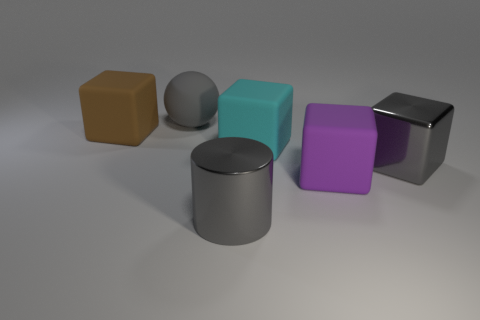Subtract all cyan cylinders. Subtract all green balls. How many cylinders are left? 1 Add 1 cyan rubber blocks. How many objects exist? 7 Subtract all spheres. How many objects are left? 5 Add 4 cylinders. How many cylinders exist? 5 Subtract 0 green balls. How many objects are left? 6 Subtract all large shiny things. Subtract all green rubber cylinders. How many objects are left? 4 Add 6 cyan cubes. How many cyan cubes are left? 7 